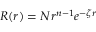Convert formula to latex. <formula><loc_0><loc_0><loc_500><loc_500>R ( r ) = N r ^ { n - 1 } e ^ { - \zeta r }</formula> 